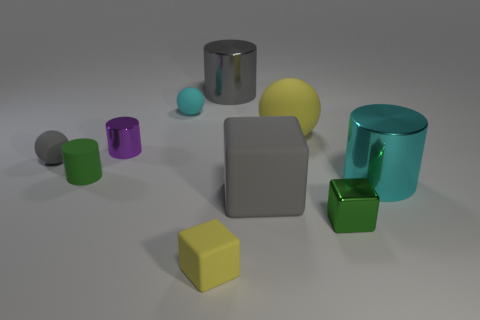Are there the same number of cyan matte spheres on the right side of the tiny shiny cylinder and cubes?
Keep it short and to the point. No. What is the size of the cyan rubber thing?
Provide a short and direct response. Small. How many yellow rubber objects are in front of the big metal thing that is to the left of the cyan metallic thing?
Your answer should be compact. 2. The matte thing that is both behind the tiny gray object and left of the big gray shiny thing has what shape?
Provide a short and direct response. Sphere. How many other metal blocks are the same color as the shiny block?
Keep it short and to the point. 0. There is a large gray object in front of the cyan thing in front of the tiny cyan matte ball; is there a big yellow ball that is in front of it?
Give a very brief answer. No. What is the size of the cylinder that is in front of the purple shiny cylinder and to the left of the cyan matte object?
Ensure brevity in your answer.  Small. How many tiny cylinders are made of the same material as the small green block?
Ensure brevity in your answer.  1. How many cylinders are red matte things or tiny green metallic objects?
Offer a terse response. 0. There is a gray thing that is to the left of the cyan thing that is to the left of the large shiny cylinder behind the tiny metal cylinder; what size is it?
Offer a terse response. Small. 